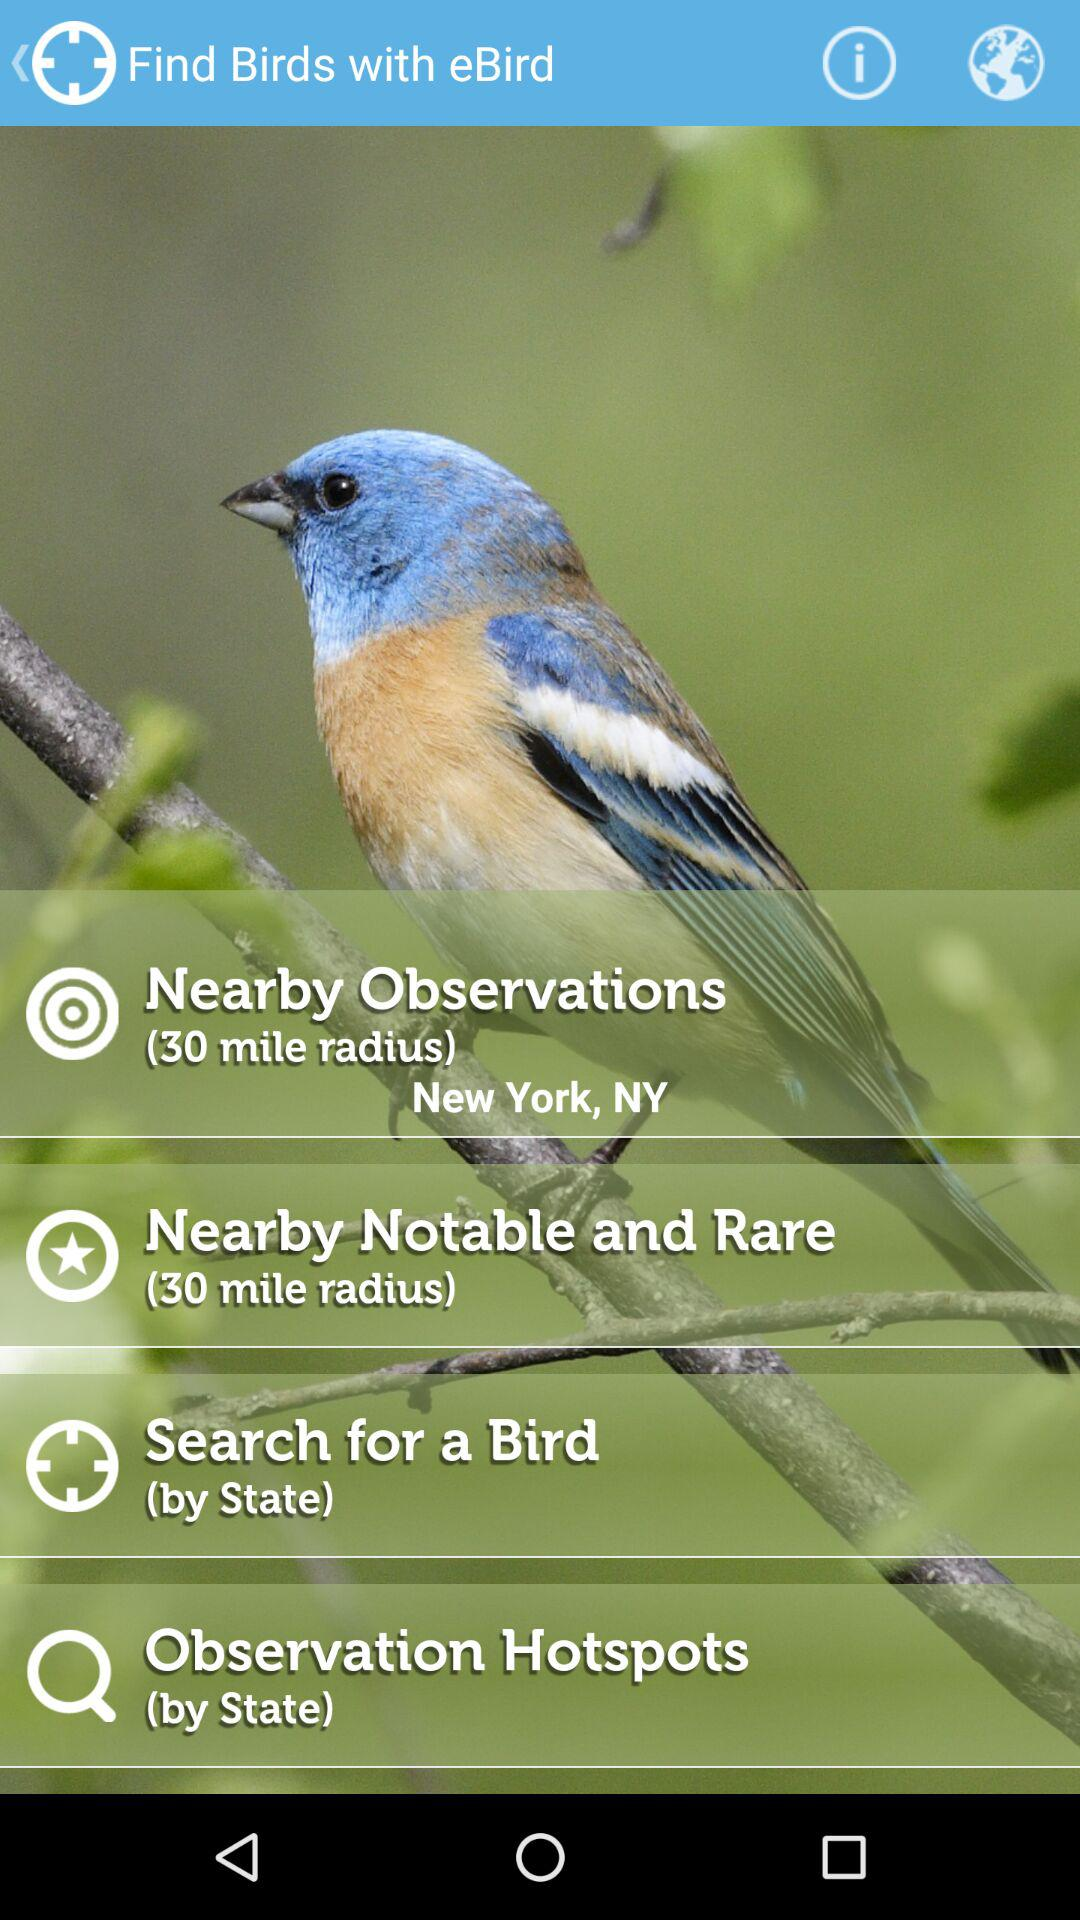What is the radius for "Nearby Notable and Rare"? The radius is 30 miles. 